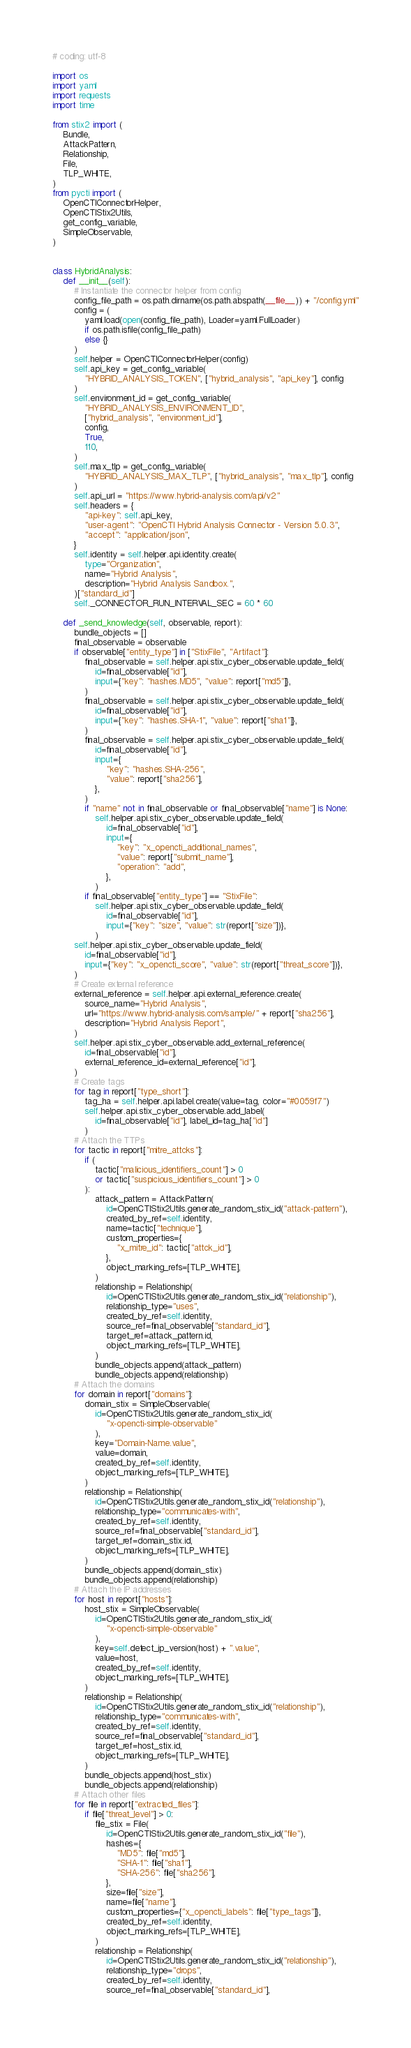Convert code to text. <code><loc_0><loc_0><loc_500><loc_500><_Python_># coding: utf-8

import os
import yaml
import requests
import time

from stix2 import (
    Bundle,
    AttackPattern,
    Relationship,
    File,
    TLP_WHITE,
)
from pycti import (
    OpenCTIConnectorHelper,
    OpenCTIStix2Utils,
    get_config_variable,
    SimpleObservable,
)


class HybridAnalysis:
    def __init__(self):
        # Instantiate the connector helper from config
        config_file_path = os.path.dirname(os.path.abspath(__file__)) + "/config.yml"
        config = (
            yaml.load(open(config_file_path), Loader=yaml.FullLoader)
            if os.path.isfile(config_file_path)
            else {}
        )
        self.helper = OpenCTIConnectorHelper(config)
        self.api_key = get_config_variable(
            "HYBRID_ANALYSIS_TOKEN", ["hybrid_analysis", "api_key"], config
        )
        self.environment_id = get_config_variable(
            "HYBRID_ANALYSIS_ENVIRONMENT_ID",
            ["hybrid_analysis", "environment_id"],
            config,
            True,
            110,
        )
        self.max_tlp = get_config_variable(
            "HYBRID_ANALYSIS_MAX_TLP", ["hybrid_analysis", "max_tlp"], config
        )
        self.api_url = "https://www.hybrid-analysis.com/api/v2"
        self.headers = {
            "api-key": self.api_key,
            "user-agent": "OpenCTI Hybrid Analysis Connector - Version 5.0.3",
            "accept": "application/json",
        }
        self.identity = self.helper.api.identity.create(
            type="Organization",
            name="Hybrid Analysis",
            description="Hybrid Analysis Sandbox.",
        )["standard_id"]
        self._CONNECTOR_RUN_INTERVAL_SEC = 60 * 60

    def _send_knowledge(self, observable, report):
        bundle_objects = []
        final_observable = observable
        if observable["entity_type"] in ["StixFile", "Artifact"]:
            final_observable = self.helper.api.stix_cyber_observable.update_field(
                id=final_observable["id"],
                input={"key": "hashes.MD5", "value": report["md5"]},
            )
            final_observable = self.helper.api.stix_cyber_observable.update_field(
                id=final_observable["id"],
                input={"key": "hashes.SHA-1", "value": report["sha1"]},
            )
            final_observable = self.helper.api.stix_cyber_observable.update_field(
                id=final_observable["id"],
                input={
                    "key": "hashes.SHA-256",
                    "value": report["sha256"],
                },
            )
            if "name" not in final_observable or final_observable["name"] is None:
                self.helper.api.stix_cyber_observable.update_field(
                    id=final_observable["id"],
                    input={
                        "key": "x_opencti_additional_names",
                        "value": report["submit_name"],
                        "operation": "add",
                    },
                )
            if final_observable["entity_type"] == "StixFile":
                self.helper.api.stix_cyber_observable.update_field(
                    id=final_observable["id"],
                    input={"key": "size", "value": str(report["size"])},
                )
        self.helper.api.stix_cyber_observable.update_field(
            id=final_observable["id"],
            input={"key": "x_opencti_score", "value": str(report["threat_score"])},
        )
        # Create external reference
        external_reference = self.helper.api.external_reference.create(
            source_name="Hybrid Analysis",
            url="https://www.hybrid-analysis.com/sample/" + report["sha256"],
            description="Hybrid Analysis Report",
        )
        self.helper.api.stix_cyber_observable.add_external_reference(
            id=final_observable["id"],
            external_reference_id=external_reference["id"],
        )
        # Create tags
        for tag in report["type_short"]:
            tag_ha = self.helper.api.label.create(value=tag, color="#0059f7")
            self.helper.api.stix_cyber_observable.add_label(
                id=final_observable["id"], label_id=tag_ha["id"]
            )
        # Attach the TTPs
        for tactic in report["mitre_attcks"]:
            if (
                tactic["malicious_identifiers_count"] > 0
                or tactic["suspicious_identifiers_count"] > 0
            ):
                attack_pattern = AttackPattern(
                    id=OpenCTIStix2Utils.generate_random_stix_id("attack-pattern"),
                    created_by_ref=self.identity,
                    name=tactic["technique"],
                    custom_properties={
                        "x_mitre_id": tactic["attck_id"],
                    },
                    object_marking_refs=[TLP_WHITE],
                )
                relationship = Relationship(
                    id=OpenCTIStix2Utils.generate_random_stix_id("relationship"),
                    relationship_type="uses",
                    created_by_ref=self.identity,
                    source_ref=final_observable["standard_id"],
                    target_ref=attack_pattern.id,
                    object_marking_refs=[TLP_WHITE],
                )
                bundle_objects.append(attack_pattern)
                bundle_objects.append(relationship)
        # Attach the domains
        for domain in report["domains"]:
            domain_stix = SimpleObservable(
                id=OpenCTIStix2Utils.generate_random_stix_id(
                    "x-opencti-simple-observable"
                ),
                key="Domain-Name.value",
                value=domain,
                created_by_ref=self.identity,
                object_marking_refs=[TLP_WHITE],
            )
            relationship = Relationship(
                id=OpenCTIStix2Utils.generate_random_stix_id("relationship"),
                relationship_type="communicates-with",
                created_by_ref=self.identity,
                source_ref=final_observable["standard_id"],
                target_ref=domain_stix.id,
                object_marking_refs=[TLP_WHITE],
            )
            bundle_objects.append(domain_stix)
            bundle_objects.append(relationship)
        # Attach the IP addresses
        for host in report["hosts"]:
            host_stix = SimpleObservable(
                id=OpenCTIStix2Utils.generate_random_stix_id(
                    "x-opencti-simple-observable"
                ),
                key=self.detect_ip_version(host) + ".value",
                value=host,
                created_by_ref=self.identity,
                object_marking_refs=[TLP_WHITE],
            )
            relationship = Relationship(
                id=OpenCTIStix2Utils.generate_random_stix_id("relationship"),
                relationship_type="communicates-with",
                created_by_ref=self.identity,
                source_ref=final_observable["standard_id"],
                target_ref=host_stix.id,
                object_marking_refs=[TLP_WHITE],
            )
            bundle_objects.append(host_stix)
            bundle_objects.append(relationship)
        # Attach other files
        for file in report["extracted_files"]:
            if file["threat_level"] > 0:
                file_stix = File(
                    id=OpenCTIStix2Utils.generate_random_stix_id("file"),
                    hashes={
                        "MD5": file["md5"],
                        "SHA-1": file["sha1"],
                        "SHA-256": file["sha256"],
                    },
                    size=file["size"],
                    name=file["name"],
                    custom_properties={"x_opencti_labels": file["type_tags"]},
                    created_by_ref=self.identity,
                    object_marking_refs=[TLP_WHITE],
                )
                relationship = Relationship(
                    id=OpenCTIStix2Utils.generate_random_stix_id("relationship"),
                    relationship_type="drops",
                    created_by_ref=self.identity,
                    source_ref=final_observable["standard_id"],</code> 